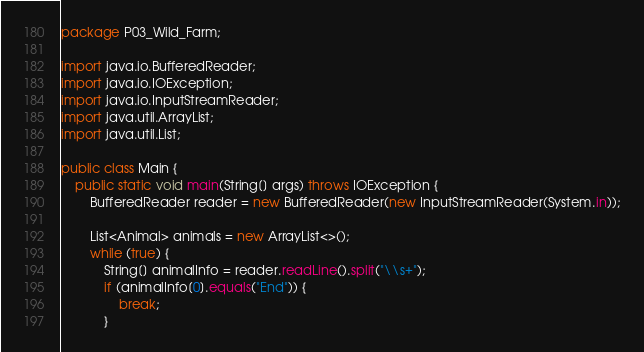Convert code to text. <code><loc_0><loc_0><loc_500><loc_500><_Java_>package P03_Wild_Farm;

import java.io.BufferedReader;
import java.io.IOException;
import java.io.InputStreamReader;
import java.util.ArrayList;
import java.util.List;

public class Main {
    public static void main(String[] args) throws IOException {
        BufferedReader reader = new BufferedReader(new InputStreamReader(System.in));

        List<Animal> animals = new ArrayList<>();
        while (true) {
            String[] animalInfo = reader.readLine().split("\\s+");
            if (animalInfo[0].equals("End")) {
                break;
            }</code> 